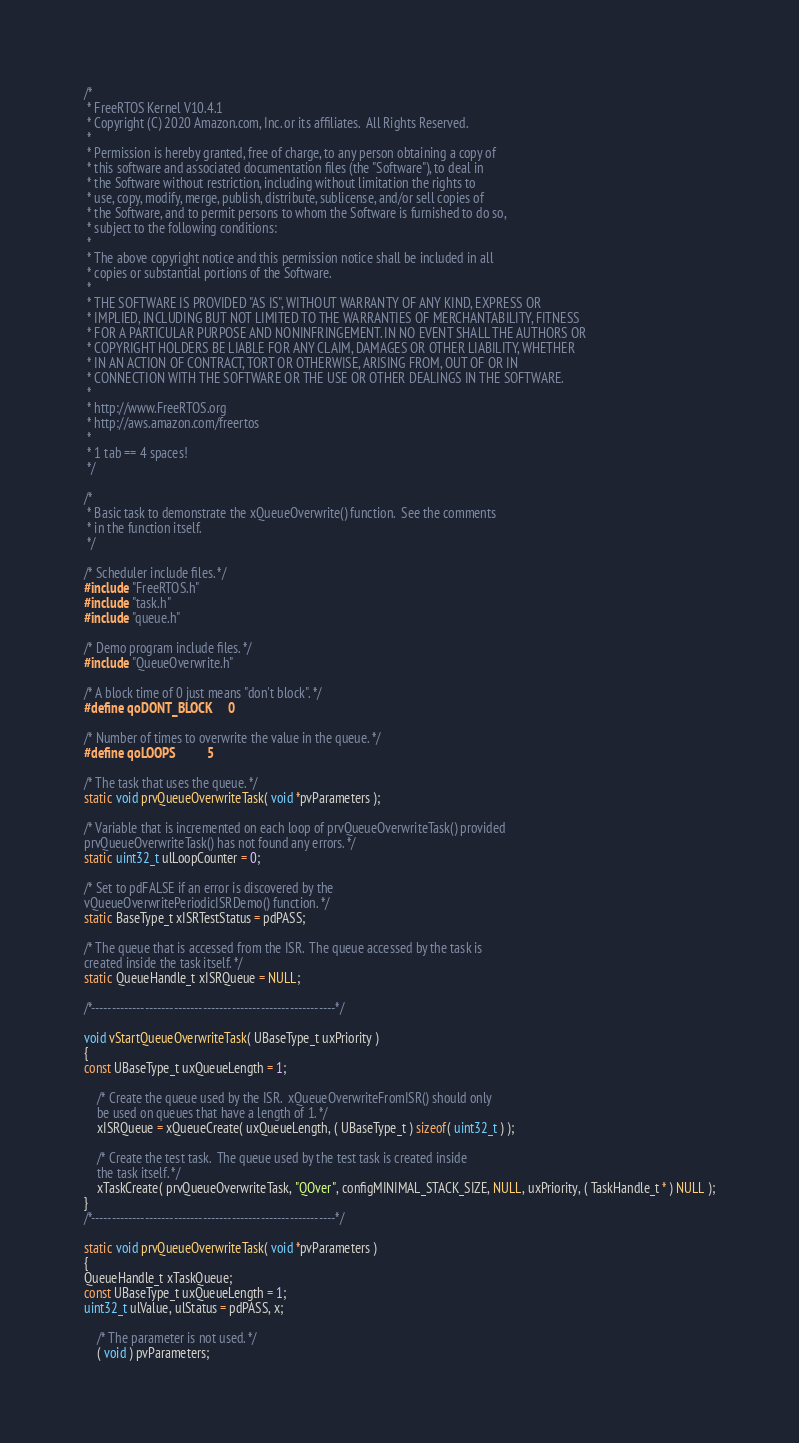Convert code to text. <code><loc_0><loc_0><loc_500><loc_500><_C_>/*
 * FreeRTOS Kernel V10.4.1
 * Copyright (C) 2020 Amazon.com, Inc. or its affiliates.  All Rights Reserved.
 *
 * Permission is hereby granted, free of charge, to any person obtaining a copy of
 * this software and associated documentation files (the "Software"), to deal in
 * the Software without restriction, including without limitation the rights to
 * use, copy, modify, merge, publish, distribute, sublicense, and/or sell copies of
 * the Software, and to permit persons to whom the Software is furnished to do so,
 * subject to the following conditions:
 *
 * The above copyright notice and this permission notice shall be included in all
 * copies or substantial portions of the Software.
 *
 * THE SOFTWARE IS PROVIDED "AS IS", WITHOUT WARRANTY OF ANY KIND, EXPRESS OR
 * IMPLIED, INCLUDING BUT NOT LIMITED TO THE WARRANTIES OF MERCHANTABILITY, FITNESS
 * FOR A PARTICULAR PURPOSE AND NONINFRINGEMENT. IN NO EVENT SHALL THE AUTHORS OR
 * COPYRIGHT HOLDERS BE LIABLE FOR ANY CLAIM, DAMAGES OR OTHER LIABILITY, WHETHER
 * IN AN ACTION OF CONTRACT, TORT OR OTHERWISE, ARISING FROM, OUT OF OR IN
 * CONNECTION WITH THE SOFTWARE OR THE USE OR OTHER DEALINGS IN THE SOFTWARE.
 *
 * http://www.FreeRTOS.org
 * http://aws.amazon.com/freertos
 *
 * 1 tab == 4 spaces!
 */

/*
 * Basic task to demonstrate the xQueueOverwrite() function.  See the comments
 * in the function itself.
 */

/* Scheduler include files. */
#include "FreeRTOS.h"
#include "task.h"
#include "queue.h"

/* Demo program include files. */
#include "QueueOverwrite.h"

/* A block time of 0 just means "don't block". */
#define qoDONT_BLOCK		0

/* Number of times to overwrite the value in the queue. */
#define qoLOOPS			5

/* The task that uses the queue. */
static void prvQueueOverwriteTask( void *pvParameters );

/* Variable that is incremented on each loop of prvQueueOverwriteTask() provided
prvQueueOverwriteTask() has not found any errors. */
static uint32_t ulLoopCounter = 0;

/* Set to pdFALSE if an error is discovered by the
vQueueOverwritePeriodicISRDemo() function. */
static BaseType_t xISRTestStatus = pdPASS;

/* The queue that is accessed from the ISR.  The queue accessed by the task is
created inside the task itself. */
static QueueHandle_t xISRQueue = NULL;

/*-----------------------------------------------------------*/

void vStartQueueOverwriteTask( UBaseType_t uxPriority )
{
const UBaseType_t uxQueueLength = 1;

	/* Create the queue used by the ISR.  xQueueOverwriteFromISR() should only
	be used on queues that have a length of 1. */
	xISRQueue = xQueueCreate( uxQueueLength, ( UBaseType_t ) sizeof( uint32_t ) );

	/* Create the test task.  The queue used by the test task is created inside
	the task itself. */
	xTaskCreate( prvQueueOverwriteTask, "QOver", configMINIMAL_STACK_SIZE, NULL, uxPriority, ( TaskHandle_t * ) NULL );
}
/*-----------------------------------------------------------*/

static void prvQueueOverwriteTask( void *pvParameters )
{
QueueHandle_t xTaskQueue;
const UBaseType_t uxQueueLength = 1;
uint32_t ulValue, ulStatus = pdPASS, x;

	/* The parameter is not used. */
	( void ) pvParameters;
</code> 